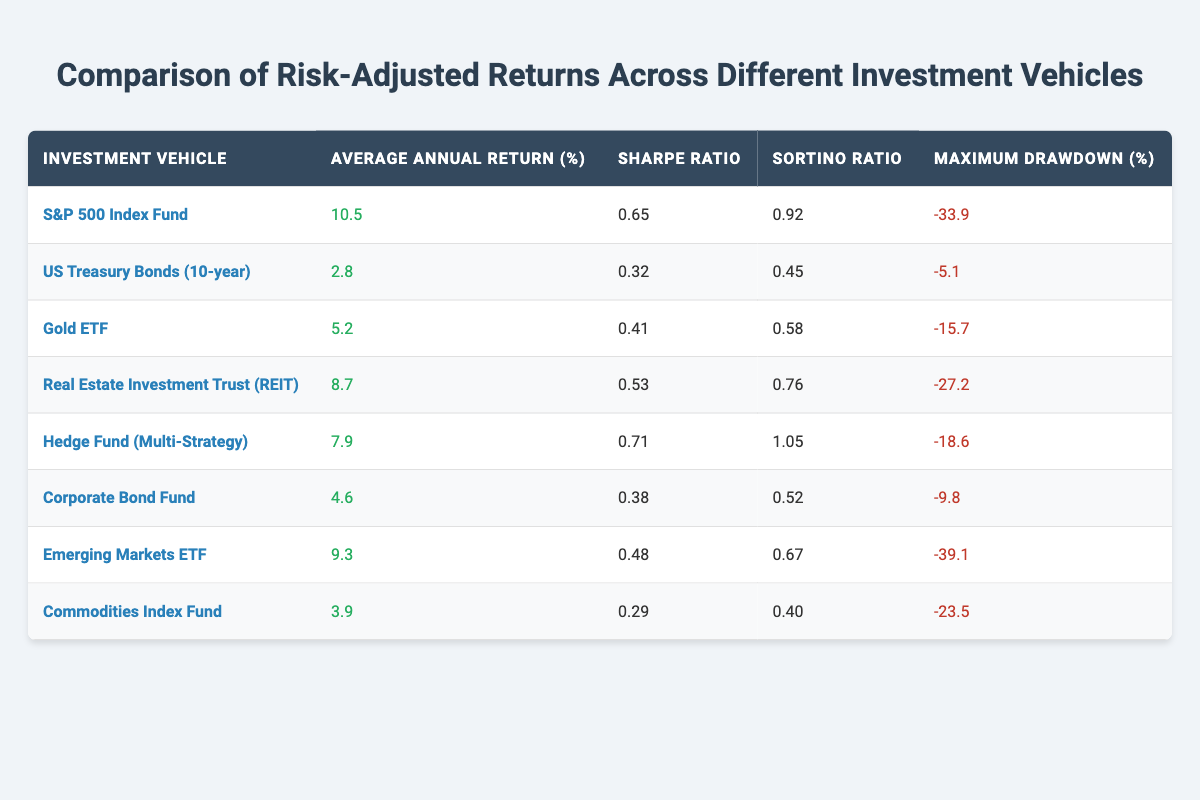What is the Average Annual Return for the S&P 500 Index Fund? The table shows the average annual return for the S&P 500 Index Fund as 10.5%.
Answer: 10.5% Which investment vehicle has the highest Sharpe Ratio? By comparing the Sharpe Ratios in the table, the Hedge Fund (Multi-Strategy) has the highest Sharpe Ratio at 0.71.
Answer: Hedge Fund (Multi-Strategy) Is the Maximum Drawdown for US Treasury Bonds greater than that of Corporate Bond Fund? The Maximum Drawdown for US Treasury Bonds is -5.1%, while that for the Corporate Bond Fund is -9.8%. Since -5.1% is less than -9.8%, it is false that the Maximum Drawdown for US Treasury Bonds is greater.
Answer: No What is the difference in Average Annual Return between the Emerging Markets ETF and the Gold ETF? The Average Annual Return for the Emerging Markets ETF is 9.3% and for the Gold ETF is 5.2%. The difference is 9.3% - 5.2% = 4.1%.
Answer: 4.1% Which investment vehicles have Sortino Ratios greater than 0.7? Looking at the table, the Hedge Fund (Multi-Strategy) has a Sortino Ratio of 1.05, and the S&P 500 Index Fund has a Sortino Ratio of 0.92. Thus, both of these vehicles qualify with Sortino Ratios greater than 0.7.
Answer: Hedge Fund (Multi-Strategy), S&P 500 Index Fund What is the Average Annual Return for all investment vehicles listed? To find this, we sum all Average Annual Returns: 10.5 + 2.8 + 5.2 + 8.7 + 7.9 + 4.6 + 9.3 + 3.9 = 52.9%. There are 8 vehicles, so the average is 52.9% / 8 = 6.6125%.
Answer: Approximately 6.61% Is the Average Annual Return for Real Estate Investment Trust (REIT) above 8%? The Average Annual Return for Real Estate Investment Trust (REIT) is 8.7%. Since 8.7% is greater than 8%, this statement is true.
Answer: Yes What is the Maximum Drawdown for Commodities Index Fund compared to the maximum from Emerging Markets ETF? The Maximum Drawdown for the Commodities Index Fund is -23.5% and for the Emerging Markets ETF is -39.1%. Since -23.5% is greater than -39.1%, this indicates that Commodities Index Fund has a better performance in this regard.
Answer: Commodities Index Fund has a better performance 